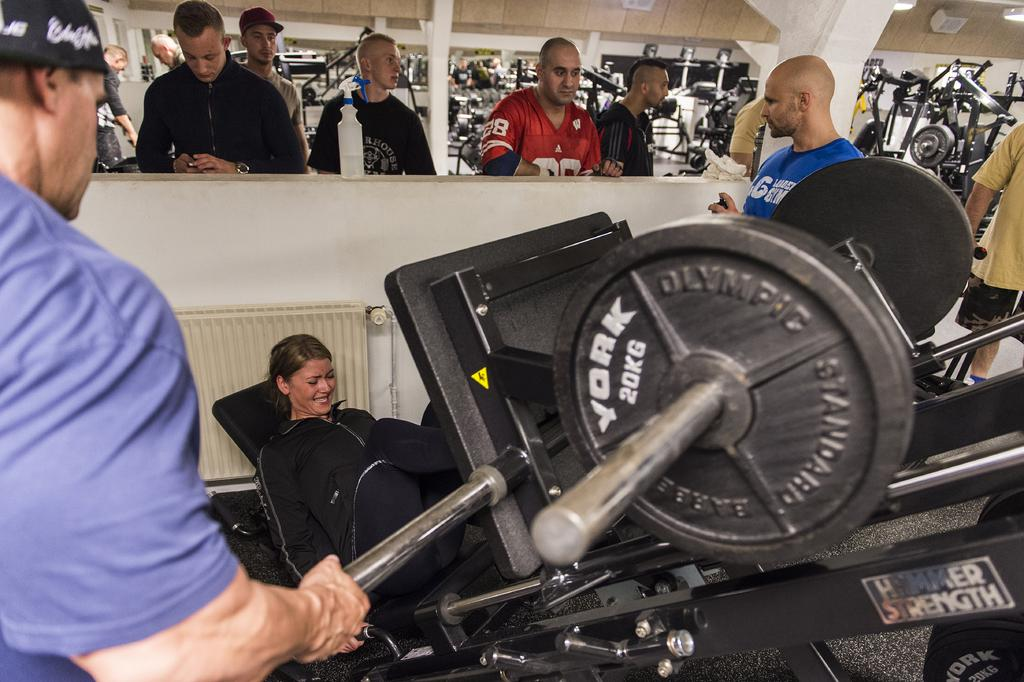What is the woman in the image doing? The woman is performing leg press in the image. What machine is the woman using for her exercise? The woman is using a leg press machine. Can you describe the people in the image? There is a group of people in the image. What can be seen in the background of the image? There are lights and gym equipment visible in the background of the image. What type of powder is being used by the woman on the throne in the image? There is no throne or powder present in the image. The woman is using a leg press machine in a gym setting. 